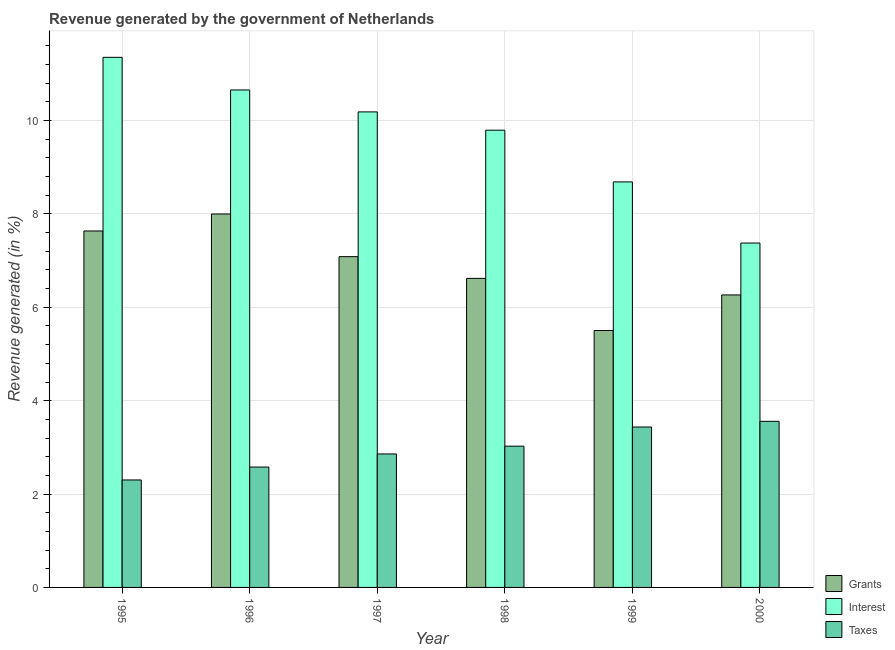How many different coloured bars are there?
Your answer should be compact. 3. How many groups of bars are there?
Your response must be concise. 6. How many bars are there on the 5th tick from the left?
Your response must be concise. 3. In how many cases, is the number of bars for a given year not equal to the number of legend labels?
Offer a terse response. 0. What is the percentage of revenue generated by taxes in 1999?
Keep it short and to the point. 3.44. Across all years, what is the maximum percentage of revenue generated by grants?
Offer a terse response. 8. Across all years, what is the minimum percentage of revenue generated by interest?
Offer a terse response. 7.38. In which year was the percentage of revenue generated by grants minimum?
Provide a short and direct response. 1999. What is the total percentage of revenue generated by interest in the graph?
Your response must be concise. 58.05. What is the difference between the percentage of revenue generated by grants in 1995 and that in 1999?
Your response must be concise. 2.13. What is the difference between the percentage of revenue generated by taxes in 1996 and the percentage of revenue generated by grants in 1995?
Your response must be concise. 0.28. What is the average percentage of revenue generated by interest per year?
Offer a very short reply. 9.68. In how many years, is the percentage of revenue generated by interest greater than 2 %?
Your answer should be compact. 6. What is the ratio of the percentage of revenue generated by taxes in 1995 to that in 1999?
Provide a succinct answer. 0.67. What is the difference between the highest and the second highest percentage of revenue generated by taxes?
Give a very brief answer. 0.12. What is the difference between the highest and the lowest percentage of revenue generated by taxes?
Provide a succinct answer. 1.26. In how many years, is the percentage of revenue generated by interest greater than the average percentage of revenue generated by interest taken over all years?
Your answer should be very brief. 4. What does the 2nd bar from the left in 1998 represents?
Give a very brief answer. Interest. What does the 2nd bar from the right in 1998 represents?
Keep it short and to the point. Interest. How many bars are there?
Make the answer very short. 18. Are all the bars in the graph horizontal?
Offer a terse response. No. How many years are there in the graph?
Make the answer very short. 6. What is the difference between two consecutive major ticks on the Y-axis?
Give a very brief answer. 2. Are the values on the major ticks of Y-axis written in scientific E-notation?
Provide a short and direct response. No. Does the graph contain grids?
Give a very brief answer. Yes. Where does the legend appear in the graph?
Make the answer very short. Bottom right. What is the title of the graph?
Your answer should be compact. Revenue generated by the government of Netherlands. What is the label or title of the X-axis?
Provide a short and direct response. Year. What is the label or title of the Y-axis?
Provide a succinct answer. Revenue generated (in %). What is the Revenue generated (in %) in Grants in 1995?
Make the answer very short. 7.63. What is the Revenue generated (in %) of Interest in 1995?
Ensure brevity in your answer.  11.35. What is the Revenue generated (in %) in Taxes in 1995?
Make the answer very short. 2.3. What is the Revenue generated (in %) of Grants in 1996?
Keep it short and to the point. 8. What is the Revenue generated (in %) in Interest in 1996?
Your response must be concise. 10.66. What is the Revenue generated (in %) in Taxes in 1996?
Offer a terse response. 2.58. What is the Revenue generated (in %) in Grants in 1997?
Keep it short and to the point. 7.09. What is the Revenue generated (in %) in Interest in 1997?
Offer a very short reply. 10.19. What is the Revenue generated (in %) of Taxes in 1997?
Offer a terse response. 2.86. What is the Revenue generated (in %) of Grants in 1998?
Provide a succinct answer. 6.62. What is the Revenue generated (in %) in Interest in 1998?
Your answer should be compact. 9.79. What is the Revenue generated (in %) of Taxes in 1998?
Ensure brevity in your answer.  3.03. What is the Revenue generated (in %) in Grants in 1999?
Offer a terse response. 5.5. What is the Revenue generated (in %) of Interest in 1999?
Make the answer very short. 8.69. What is the Revenue generated (in %) of Taxes in 1999?
Keep it short and to the point. 3.44. What is the Revenue generated (in %) of Grants in 2000?
Offer a terse response. 6.27. What is the Revenue generated (in %) of Interest in 2000?
Offer a terse response. 7.38. What is the Revenue generated (in %) of Taxes in 2000?
Your response must be concise. 3.56. Across all years, what is the maximum Revenue generated (in %) of Grants?
Provide a short and direct response. 8. Across all years, what is the maximum Revenue generated (in %) in Interest?
Your response must be concise. 11.35. Across all years, what is the maximum Revenue generated (in %) in Taxes?
Ensure brevity in your answer.  3.56. Across all years, what is the minimum Revenue generated (in %) in Grants?
Offer a very short reply. 5.5. Across all years, what is the minimum Revenue generated (in %) of Interest?
Offer a terse response. 7.38. Across all years, what is the minimum Revenue generated (in %) of Taxes?
Provide a succinct answer. 2.3. What is the total Revenue generated (in %) in Grants in the graph?
Keep it short and to the point. 41.11. What is the total Revenue generated (in %) of Interest in the graph?
Your answer should be very brief. 58.05. What is the total Revenue generated (in %) of Taxes in the graph?
Your answer should be compact. 17.76. What is the difference between the Revenue generated (in %) in Grants in 1995 and that in 1996?
Keep it short and to the point. -0.36. What is the difference between the Revenue generated (in %) in Interest in 1995 and that in 1996?
Your answer should be compact. 0.7. What is the difference between the Revenue generated (in %) in Taxes in 1995 and that in 1996?
Ensure brevity in your answer.  -0.28. What is the difference between the Revenue generated (in %) of Grants in 1995 and that in 1997?
Keep it short and to the point. 0.55. What is the difference between the Revenue generated (in %) in Interest in 1995 and that in 1997?
Provide a succinct answer. 1.17. What is the difference between the Revenue generated (in %) in Taxes in 1995 and that in 1997?
Provide a succinct answer. -0.56. What is the difference between the Revenue generated (in %) in Grants in 1995 and that in 1998?
Your answer should be compact. 1.02. What is the difference between the Revenue generated (in %) of Interest in 1995 and that in 1998?
Provide a succinct answer. 1.56. What is the difference between the Revenue generated (in %) of Taxes in 1995 and that in 1998?
Offer a very short reply. -0.72. What is the difference between the Revenue generated (in %) in Grants in 1995 and that in 1999?
Your response must be concise. 2.13. What is the difference between the Revenue generated (in %) in Interest in 1995 and that in 1999?
Give a very brief answer. 2.67. What is the difference between the Revenue generated (in %) of Taxes in 1995 and that in 1999?
Provide a short and direct response. -1.13. What is the difference between the Revenue generated (in %) in Grants in 1995 and that in 2000?
Ensure brevity in your answer.  1.37. What is the difference between the Revenue generated (in %) of Interest in 1995 and that in 2000?
Provide a short and direct response. 3.98. What is the difference between the Revenue generated (in %) of Taxes in 1995 and that in 2000?
Give a very brief answer. -1.26. What is the difference between the Revenue generated (in %) of Grants in 1996 and that in 1997?
Ensure brevity in your answer.  0.91. What is the difference between the Revenue generated (in %) in Interest in 1996 and that in 1997?
Offer a very short reply. 0.47. What is the difference between the Revenue generated (in %) in Taxes in 1996 and that in 1997?
Provide a short and direct response. -0.28. What is the difference between the Revenue generated (in %) of Grants in 1996 and that in 1998?
Your answer should be very brief. 1.38. What is the difference between the Revenue generated (in %) of Interest in 1996 and that in 1998?
Keep it short and to the point. 0.86. What is the difference between the Revenue generated (in %) in Taxes in 1996 and that in 1998?
Provide a succinct answer. -0.45. What is the difference between the Revenue generated (in %) in Grants in 1996 and that in 1999?
Ensure brevity in your answer.  2.5. What is the difference between the Revenue generated (in %) of Interest in 1996 and that in 1999?
Your answer should be very brief. 1.97. What is the difference between the Revenue generated (in %) of Taxes in 1996 and that in 1999?
Ensure brevity in your answer.  -0.86. What is the difference between the Revenue generated (in %) of Grants in 1996 and that in 2000?
Give a very brief answer. 1.73. What is the difference between the Revenue generated (in %) of Interest in 1996 and that in 2000?
Keep it short and to the point. 3.28. What is the difference between the Revenue generated (in %) in Taxes in 1996 and that in 2000?
Your answer should be very brief. -0.98. What is the difference between the Revenue generated (in %) in Grants in 1997 and that in 1998?
Give a very brief answer. 0.47. What is the difference between the Revenue generated (in %) of Interest in 1997 and that in 1998?
Keep it short and to the point. 0.39. What is the difference between the Revenue generated (in %) of Taxes in 1997 and that in 1998?
Offer a very short reply. -0.17. What is the difference between the Revenue generated (in %) of Grants in 1997 and that in 1999?
Offer a very short reply. 1.58. What is the difference between the Revenue generated (in %) in Interest in 1997 and that in 1999?
Offer a terse response. 1.5. What is the difference between the Revenue generated (in %) in Taxes in 1997 and that in 1999?
Provide a short and direct response. -0.58. What is the difference between the Revenue generated (in %) of Grants in 1997 and that in 2000?
Your answer should be very brief. 0.82. What is the difference between the Revenue generated (in %) of Interest in 1997 and that in 2000?
Keep it short and to the point. 2.81. What is the difference between the Revenue generated (in %) of Taxes in 1997 and that in 2000?
Make the answer very short. -0.7. What is the difference between the Revenue generated (in %) of Grants in 1998 and that in 1999?
Provide a short and direct response. 1.12. What is the difference between the Revenue generated (in %) of Interest in 1998 and that in 1999?
Provide a succinct answer. 1.11. What is the difference between the Revenue generated (in %) in Taxes in 1998 and that in 1999?
Provide a succinct answer. -0.41. What is the difference between the Revenue generated (in %) in Grants in 1998 and that in 2000?
Your response must be concise. 0.35. What is the difference between the Revenue generated (in %) in Interest in 1998 and that in 2000?
Provide a short and direct response. 2.42. What is the difference between the Revenue generated (in %) in Taxes in 1998 and that in 2000?
Your answer should be very brief. -0.53. What is the difference between the Revenue generated (in %) of Grants in 1999 and that in 2000?
Offer a terse response. -0.76. What is the difference between the Revenue generated (in %) in Interest in 1999 and that in 2000?
Offer a terse response. 1.31. What is the difference between the Revenue generated (in %) in Taxes in 1999 and that in 2000?
Give a very brief answer. -0.12. What is the difference between the Revenue generated (in %) of Grants in 1995 and the Revenue generated (in %) of Interest in 1996?
Offer a very short reply. -3.02. What is the difference between the Revenue generated (in %) of Grants in 1995 and the Revenue generated (in %) of Taxes in 1996?
Your answer should be compact. 5.06. What is the difference between the Revenue generated (in %) in Interest in 1995 and the Revenue generated (in %) in Taxes in 1996?
Your response must be concise. 8.78. What is the difference between the Revenue generated (in %) in Grants in 1995 and the Revenue generated (in %) in Interest in 1997?
Offer a terse response. -2.55. What is the difference between the Revenue generated (in %) in Grants in 1995 and the Revenue generated (in %) in Taxes in 1997?
Ensure brevity in your answer.  4.78. What is the difference between the Revenue generated (in %) of Interest in 1995 and the Revenue generated (in %) of Taxes in 1997?
Provide a short and direct response. 8.5. What is the difference between the Revenue generated (in %) of Grants in 1995 and the Revenue generated (in %) of Interest in 1998?
Keep it short and to the point. -2.16. What is the difference between the Revenue generated (in %) in Grants in 1995 and the Revenue generated (in %) in Taxes in 1998?
Your answer should be compact. 4.61. What is the difference between the Revenue generated (in %) in Interest in 1995 and the Revenue generated (in %) in Taxes in 1998?
Make the answer very short. 8.33. What is the difference between the Revenue generated (in %) in Grants in 1995 and the Revenue generated (in %) in Interest in 1999?
Make the answer very short. -1.05. What is the difference between the Revenue generated (in %) of Grants in 1995 and the Revenue generated (in %) of Taxes in 1999?
Offer a very short reply. 4.2. What is the difference between the Revenue generated (in %) in Interest in 1995 and the Revenue generated (in %) in Taxes in 1999?
Make the answer very short. 7.92. What is the difference between the Revenue generated (in %) in Grants in 1995 and the Revenue generated (in %) in Interest in 2000?
Ensure brevity in your answer.  0.26. What is the difference between the Revenue generated (in %) in Grants in 1995 and the Revenue generated (in %) in Taxes in 2000?
Your answer should be compact. 4.08. What is the difference between the Revenue generated (in %) in Interest in 1995 and the Revenue generated (in %) in Taxes in 2000?
Your response must be concise. 7.8. What is the difference between the Revenue generated (in %) of Grants in 1996 and the Revenue generated (in %) of Interest in 1997?
Your answer should be compact. -2.19. What is the difference between the Revenue generated (in %) in Grants in 1996 and the Revenue generated (in %) in Taxes in 1997?
Offer a very short reply. 5.14. What is the difference between the Revenue generated (in %) of Interest in 1996 and the Revenue generated (in %) of Taxes in 1997?
Offer a very short reply. 7.8. What is the difference between the Revenue generated (in %) of Grants in 1996 and the Revenue generated (in %) of Interest in 1998?
Your answer should be compact. -1.79. What is the difference between the Revenue generated (in %) of Grants in 1996 and the Revenue generated (in %) of Taxes in 1998?
Ensure brevity in your answer.  4.97. What is the difference between the Revenue generated (in %) of Interest in 1996 and the Revenue generated (in %) of Taxes in 1998?
Make the answer very short. 7.63. What is the difference between the Revenue generated (in %) of Grants in 1996 and the Revenue generated (in %) of Interest in 1999?
Your answer should be compact. -0.69. What is the difference between the Revenue generated (in %) of Grants in 1996 and the Revenue generated (in %) of Taxes in 1999?
Make the answer very short. 4.56. What is the difference between the Revenue generated (in %) of Interest in 1996 and the Revenue generated (in %) of Taxes in 1999?
Your response must be concise. 7.22. What is the difference between the Revenue generated (in %) of Grants in 1996 and the Revenue generated (in %) of Interest in 2000?
Ensure brevity in your answer.  0.62. What is the difference between the Revenue generated (in %) in Grants in 1996 and the Revenue generated (in %) in Taxes in 2000?
Offer a very short reply. 4.44. What is the difference between the Revenue generated (in %) of Interest in 1996 and the Revenue generated (in %) of Taxes in 2000?
Keep it short and to the point. 7.1. What is the difference between the Revenue generated (in %) of Grants in 1997 and the Revenue generated (in %) of Interest in 1998?
Ensure brevity in your answer.  -2.71. What is the difference between the Revenue generated (in %) in Grants in 1997 and the Revenue generated (in %) in Taxes in 1998?
Your response must be concise. 4.06. What is the difference between the Revenue generated (in %) of Interest in 1997 and the Revenue generated (in %) of Taxes in 1998?
Offer a very short reply. 7.16. What is the difference between the Revenue generated (in %) in Grants in 1997 and the Revenue generated (in %) in Interest in 1999?
Keep it short and to the point. -1.6. What is the difference between the Revenue generated (in %) in Grants in 1997 and the Revenue generated (in %) in Taxes in 1999?
Provide a succinct answer. 3.65. What is the difference between the Revenue generated (in %) in Interest in 1997 and the Revenue generated (in %) in Taxes in 1999?
Your response must be concise. 6.75. What is the difference between the Revenue generated (in %) in Grants in 1997 and the Revenue generated (in %) in Interest in 2000?
Offer a terse response. -0.29. What is the difference between the Revenue generated (in %) in Grants in 1997 and the Revenue generated (in %) in Taxes in 2000?
Provide a short and direct response. 3.53. What is the difference between the Revenue generated (in %) in Interest in 1997 and the Revenue generated (in %) in Taxes in 2000?
Provide a succinct answer. 6.63. What is the difference between the Revenue generated (in %) in Grants in 1998 and the Revenue generated (in %) in Interest in 1999?
Keep it short and to the point. -2.07. What is the difference between the Revenue generated (in %) in Grants in 1998 and the Revenue generated (in %) in Taxes in 1999?
Make the answer very short. 3.18. What is the difference between the Revenue generated (in %) in Interest in 1998 and the Revenue generated (in %) in Taxes in 1999?
Your answer should be compact. 6.36. What is the difference between the Revenue generated (in %) in Grants in 1998 and the Revenue generated (in %) in Interest in 2000?
Your response must be concise. -0.76. What is the difference between the Revenue generated (in %) of Grants in 1998 and the Revenue generated (in %) of Taxes in 2000?
Make the answer very short. 3.06. What is the difference between the Revenue generated (in %) of Interest in 1998 and the Revenue generated (in %) of Taxes in 2000?
Make the answer very short. 6.24. What is the difference between the Revenue generated (in %) of Grants in 1999 and the Revenue generated (in %) of Interest in 2000?
Your answer should be compact. -1.87. What is the difference between the Revenue generated (in %) in Grants in 1999 and the Revenue generated (in %) in Taxes in 2000?
Give a very brief answer. 1.95. What is the difference between the Revenue generated (in %) of Interest in 1999 and the Revenue generated (in %) of Taxes in 2000?
Provide a short and direct response. 5.13. What is the average Revenue generated (in %) of Grants per year?
Make the answer very short. 6.85. What is the average Revenue generated (in %) of Interest per year?
Offer a very short reply. 9.68. What is the average Revenue generated (in %) of Taxes per year?
Your response must be concise. 2.96. In the year 1995, what is the difference between the Revenue generated (in %) in Grants and Revenue generated (in %) in Interest?
Make the answer very short. -3.72. In the year 1995, what is the difference between the Revenue generated (in %) of Grants and Revenue generated (in %) of Taxes?
Provide a short and direct response. 5.33. In the year 1995, what is the difference between the Revenue generated (in %) of Interest and Revenue generated (in %) of Taxes?
Keep it short and to the point. 9.05. In the year 1996, what is the difference between the Revenue generated (in %) of Grants and Revenue generated (in %) of Interest?
Ensure brevity in your answer.  -2.66. In the year 1996, what is the difference between the Revenue generated (in %) of Grants and Revenue generated (in %) of Taxes?
Ensure brevity in your answer.  5.42. In the year 1996, what is the difference between the Revenue generated (in %) of Interest and Revenue generated (in %) of Taxes?
Your response must be concise. 8.08. In the year 1997, what is the difference between the Revenue generated (in %) in Grants and Revenue generated (in %) in Interest?
Offer a terse response. -3.1. In the year 1997, what is the difference between the Revenue generated (in %) in Grants and Revenue generated (in %) in Taxes?
Your answer should be very brief. 4.23. In the year 1997, what is the difference between the Revenue generated (in %) of Interest and Revenue generated (in %) of Taxes?
Offer a terse response. 7.33. In the year 1998, what is the difference between the Revenue generated (in %) in Grants and Revenue generated (in %) in Interest?
Your answer should be compact. -3.17. In the year 1998, what is the difference between the Revenue generated (in %) of Grants and Revenue generated (in %) of Taxes?
Your answer should be compact. 3.59. In the year 1998, what is the difference between the Revenue generated (in %) in Interest and Revenue generated (in %) in Taxes?
Your response must be concise. 6.77. In the year 1999, what is the difference between the Revenue generated (in %) of Grants and Revenue generated (in %) of Interest?
Make the answer very short. -3.18. In the year 1999, what is the difference between the Revenue generated (in %) in Grants and Revenue generated (in %) in Taxes?
Your answer should be compact. 2.07. In the year 1999, what is the difference between the Revenue generated (in %) in Interest and Revenue generated (in %) in Taxes?
Keep it short and to the point. 5.25. In the year 2000, what is the difference between the Revenue generated (in %) of Grants and Revenue generated (in %) of Interest?
Give a very brief answer. -1.11. In the year 2000, what is the difference between the Revenue generated (in %) of Grants and Revenue generated (in %) of Taxes?
Provide a short and direct response. 2.71. In the year 2000, what is the difference between the Revenue generated (in %) in Interest and Revenue generated (in %) in Taxes?
Give a very brief answer. 3.82. What is the ratio of the Revenue generated (in %) of Grants in 1995 to that in 1996?
Give a very brief answer. 0.95. What is the ratio of the Revenue generated (in %) of Interest in 1995 to that in 1996?
Keep it short and to the point. 1.07. What is the ratio of the Revenue generated (in %) in Taxes in 1995 to that in 1996?
Your response must be concise. 0.89. What is the ratio of the Revenue generated (in %) in Grants in 1995 to that in 1997?
Ensure brevity in your answer.  1.08. What is the ratio of the Revenue generated (in %) in Interest in 1995 to that in 1997?
Offer a terse response. 1.11. What is the ratio of the Revenue generated (in %) of Taxes in 1995 to that in 1997?
Offer a terse response. 0.81. What is the ratio of the Revenue generated (in %) of Grants in 1995 to that in 1998?
Make the answer very short. 1.15. What is the ratio of the Revenue generated (in %) of Interest in 1995 to that in 1998?
Give a very brief answer. 1.16. What is the ratio of the Revenue generated (in %) in Taxes in 1995 to that in 1998?
Provide a succinct answer. 0.76. What is the ratio of the Revenue generated (in %) in Grants in 1995 to that in 1999?
Give a very brief answer. 1.39. What is the ratio of the Revenue generated (in %) of Interest in 1995 to that in 1999?
Offer a terse response. 1.31. What is the ratio of the Revenue generated (in %) in Taxes in 1995 to that in 1999?
Offer a terse response. 0.67. What is the ratio of the Revenue generated (in %) of Grants in 1995 to that in 2000?
Keep it short and to the point. 1.22. What is the ratio of the Revenue generated (in %) of Interest in 1995 to that in 2000?
Make the answer very short. 1.54. What is the ratio of the Revenue generated (in %) of Taxes in 1995 to that in 2000?
Ensure brevity in your answer.  0.65. What is the ratio of the Revenue generated (in %) in Grants in 1996 to that in 1997?
Keep it short and to the point. 1.13. What is the ratio of the Revenue generated (in %) in Interest in 1996 to that in 1997?
Your answer should be very brief. 1.05. What is the ratio of the Revenue generated (in %) in Taxes in 1996 to that in 1997?
Make the answer very short. 0.9. What is the ratio of the Revenue generated (in %) in Grants in 1996 to that in 1998?
Make the answer very short. 1.21. What is the ratio of the Revenue generated (in %) in Interest in 1996 to that in 1998?
Your answer should be very brief. 1.09. What is the ratio of the Revenue generated (in %) of Taxes in 1996 to that in 1998?
Your response must be concise. 0.85. What is the ratio of the Revenue generated (in %) of Grants in 1996 to that in 1999?
Offer a terse response. 1.45. What is the ratio of the Revenue generated (in %) in Interest in 1996 to that in 1999?
Your answer should be compact. 1.23. What is the ratio of the Revenue generated (in %) of Taxes in 1996 to that in 1999?
Your response must be concise. 0.75. What is the ratio of the Revenue generated (in %) of Grants in 1996 to that in 2000?
Keep it short and to the point. 1.28. What is the ratio of the Revenue generated (in %) of Interest in 1996 to that in 2000?
Make the answer very short. 1.44. What is the ratio of the Revenue generated (in %) of Taxes in 1996 to that in 2000?
Offer a terse response. 0.72. What is the ratio of the Revenue generated (in %) in Grants in 1997 to that in 1998?
Offer a terse response. 1.07. What is the ratio of the Revenue generated (in %) in Taxes in 1997 to that in 1998?
Give a very brief answer. 0.94. What is the ratio of the Revenue generated (in %) in Grants in 1997 to that in 1999?
Keep it short and to the point. 1.29. What is the ratio of the Revenue generated (in %) of Interest in 1997 to that in 1999?
Your response must be concise. 1.17. What is the ratio of the Revenue generated (in %) in Taxes in 1997 to that in 1999?
Offer a terse response. 0.83. What is the ratio of the Revenue generated (in %) in Grants in 1997 to that in 2000?
Your response must be concise. 1.13. What is the ratio of the Revenue generated (in %) of Interest in 1997 to that in 2000?
Provide a short and direct response. 1.38. What is the ratio of the Revenue generated (in %) of Taxes in 1997 to that in 2000?
Provide a succinct answer. 0.8. What is the ratio of the Revenue generated (in %) of Grants in 1998 to that in 1999?
Provide a short and direct response. 1.2. What is the ratio of the Revenue generated (in %) in Interest in 1998 to that in 1999?
Make the answer very short. 1.13. What is the ratio of the Revenue generated (in %) of Taxes in 1998 to that in 1999?
Provide a short and direct response. 0.88. What is the ratio of the Revenue generated (in %) of Grants in 1998 to that in 2000?
Keep it short and to the point. 1.06. What is the ratio of the Revenue generated (in %) in Interest in 1998 to that in 2000?
Provide a succinct answer. 1.33. What is the ratio of the Revenue generated (in %) in Taxes in 1998 to that in 2000?
Keep it short and to the point. 0.85. What is the ratio of the Revenue generated (in %) of Grants in 1999 to that in 2000?
Make the answer very short. 0.88. What is the ratio of the Revenue generated (in %) of Interest in 1999 to that in 2000?
Make the answer very short. 1.18. What is the ratio of the Revenue generated (in %) in Taxes in 1999 to that in 2000?
Provide a short and direct response. 0.97. What is the difference between the highest and the second highest Revenue generated (in %) of Grants?
Keep it short and to the point. 0.36. What is the difference between the highest and the second highest Revenue generated (in %) of Interest?
Ensure brevity in your answer.  0.7. What is the difference between the highest and the second highest Revenue generated (in %) of Taxes?
Provide a short and direct response. 0.12. What is the difference between the highest and the lowest Revenue generated (in %) in Grants?
Ensure brevity in your answer.  2.5. What is the difference between the highest and the lowest Revenue generated (in %) of Interest?
Make the answer very short. 3.98. What is the difference between the highest and the lowest Revenue generated (in %) in Taxes?
Provide a short and direct response. 1.26. 